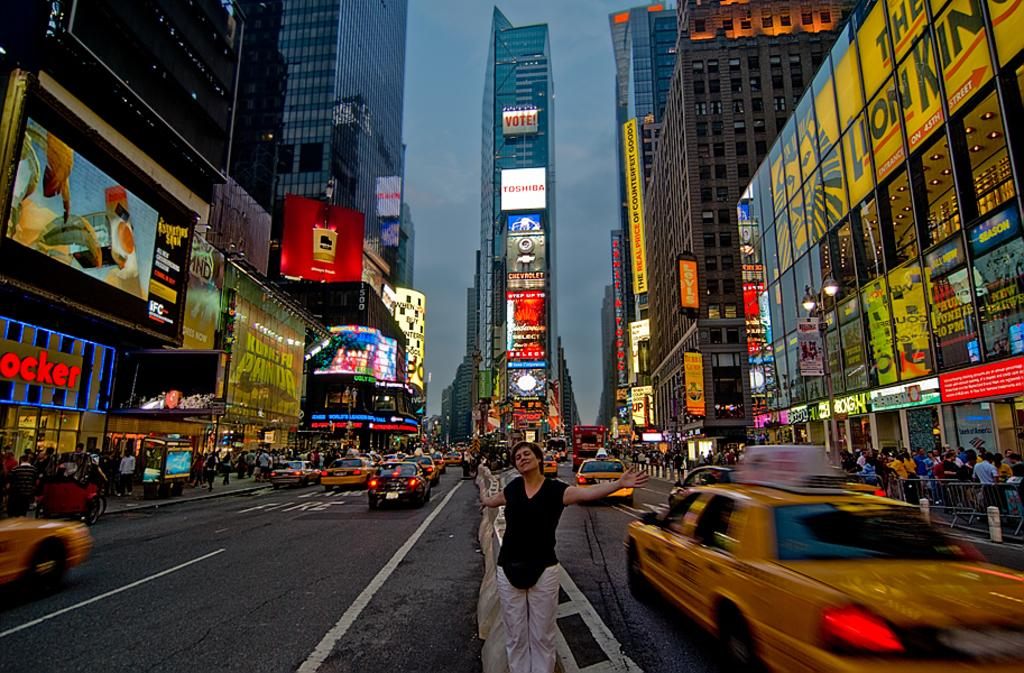<image>
Offer a succinct explanation of the picture presented. a street with a store that has ocker on the side 